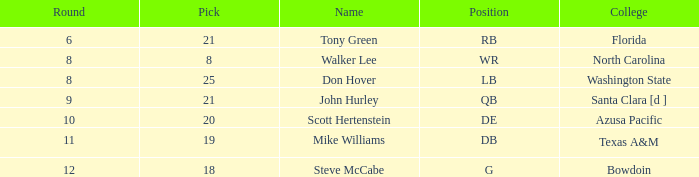Would you be able to parse every entry in this table? {'header': ['Round', 'Pick', 'Name', 'Position', 'College'], 'rows': [['6', '21', 'Tony Green', 'RB', 'Florida'], ['8', '8', 'Walker Lee', 'WR', 'North Carolina'], ['8', '25', 'Don Hover', 'LB', 'Washington State'], ['9', '21', 'John Hurley', 'QB', 'Santa Clara [d ]'], ['10', '20', 'Scott Hertenstein', 'DE', 'Azusa Pacific'], ['11', '19', 'Mike Williams', 'DB', 'Texas A&M'], ['12', '18', 'Steve McCabe', 'G', 'Bowdoin']]} Which university has a selection below 25, a total higher than 159, a round under 10, and a wide receiver as the position? North Carolina. 